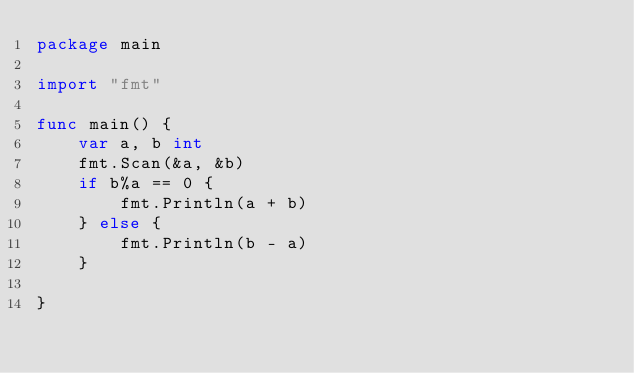<code> <loc_0><loc_0><loc_500><loc_500><_Go_>package main

import "fmt"

func main() {
	var a, b int
	fmt.Scan(&a, &b)
	if b%a == 0 {
		fmt.Println(a + b)
	} else {
		fmt.Println(b - a)
	}

}
</code> 